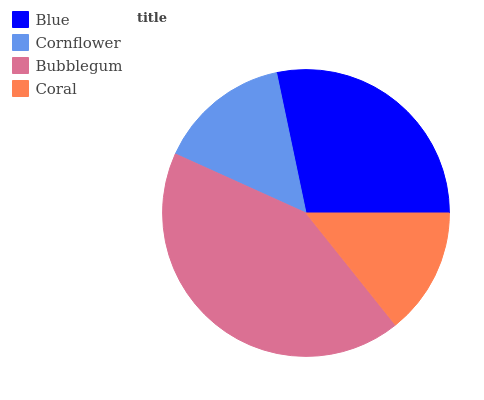Is Coral the minimum?
Answer yes or no. Yes. Is Bubblegum the maximum?
Answer yes or no. Yes. Is Cornflower the minimum?
Answer yes or no. No. Is Cornflower the maximum?
Answer yes or no. No. Is Blue greater than Cornflower?
Answer yes or no. Yes. Is Cornflower less than Blue?
Answer yes or no. Yes. Is Cornflower greater than Blue?
Answer yes or no. No. Is Blue less than Cornflower?
Answer yes or no. No. Is Blue the high median?
Answer yes or no. Yes. Is Cornflower the low median?
Answer yes or no. Yes. Is Coral the high median?
Answer yes or no. No. Is Bubblegum the low median?
Answer yes or no. No. 